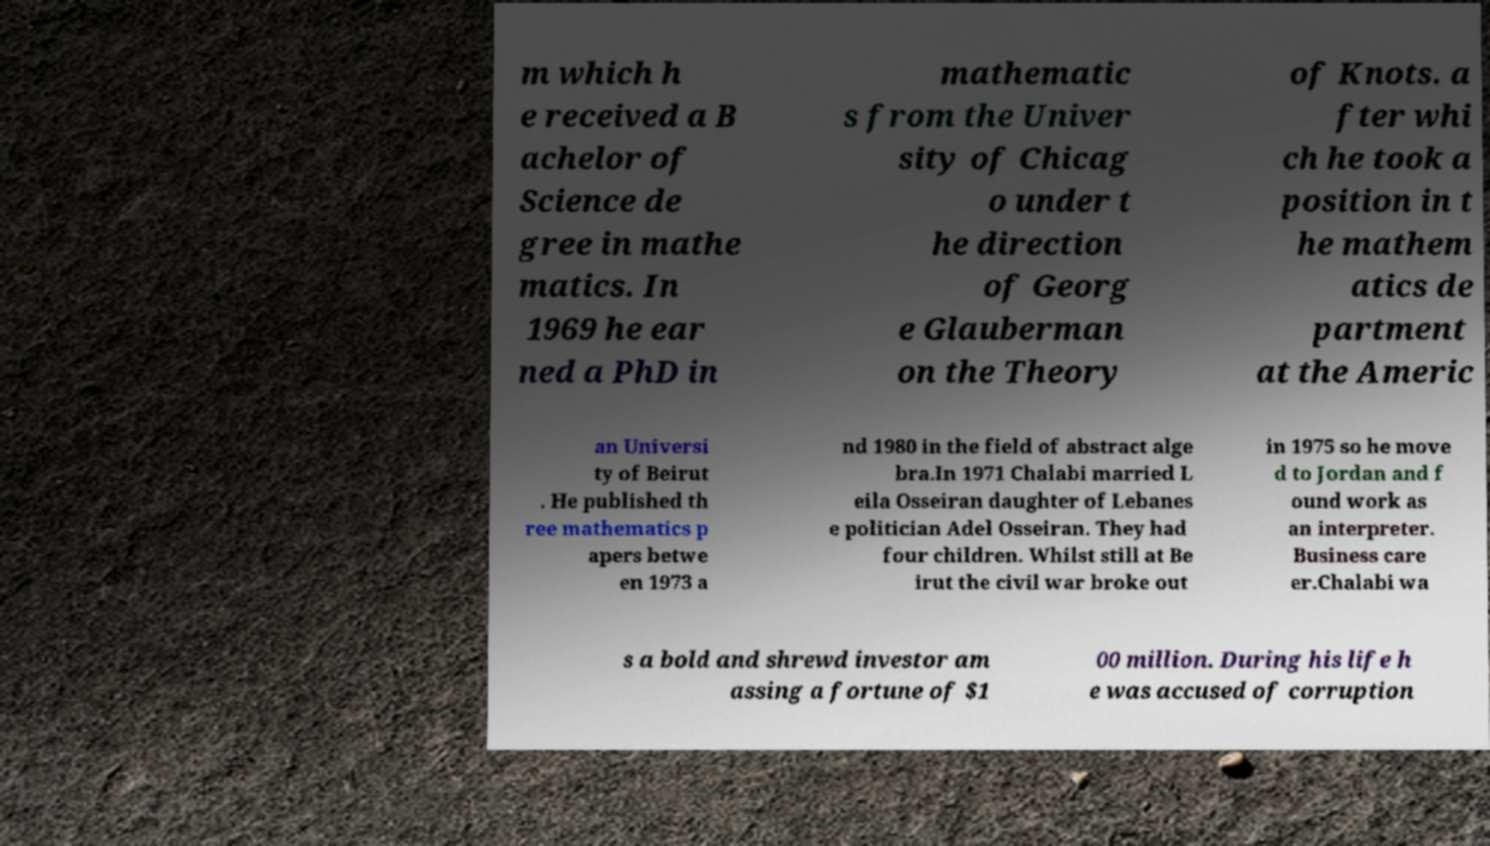Could you assist in decoding the text presented in this image and type it out clearly? m which h e received a B achelor of Science de gree in mathe matics. In 1969 he ear ned a PhD in mathematic s from the Univer sity of Chicag o under t he direction of Georg e Glauberman on the Theory of Knots. a fter whi ch he took a position in t he mathem atics de partment at the Americ an Universi ty of Beirut . He published th ree mathematics p apers betwe en 1973 a nd 1980 in the field of abstract alge bra.In 1971 Chalabi married L eila Osseiran daughter of Lebanes e politician Adel Osseiran. They had four children. Whilst still at Be irut the civil war broke out in 1975 so he move d to Jordan and f ound work as an interpreter. Business care er.Chalabi wa s a bold and shrewd investor am assing a fortune of $1 00 million. During his life h e was accused of corruption 